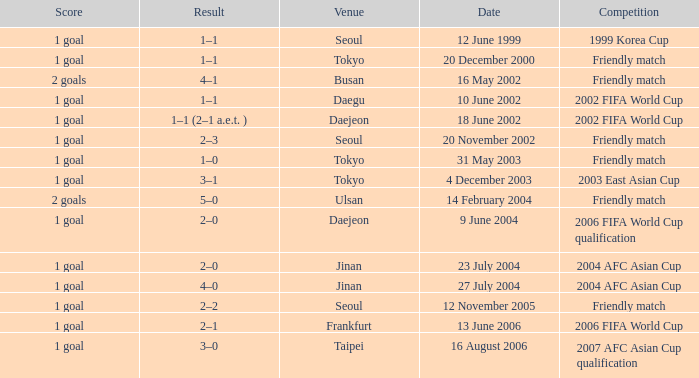What is the location for the event on 12 november 2005? Seoul. 